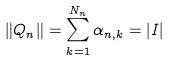<formula> <loc_0><loc_0><loc_500><loc_500>\| Q _ { n } \| = \sum _ { k = 1 } ^ { N _ { n } } \alpha _ { n , k } = | I |</formula> 